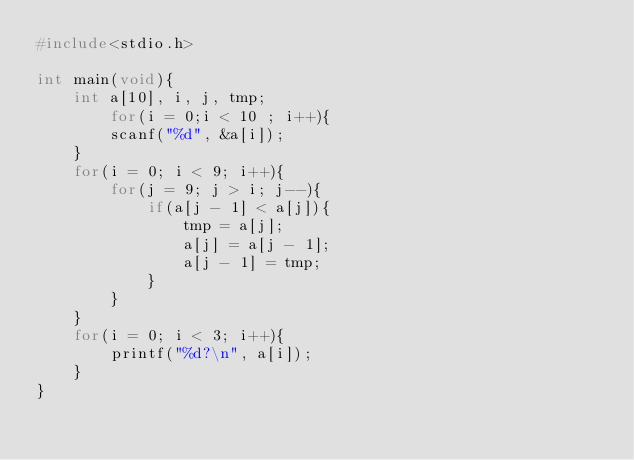<code> <loc_0><loc_0><loc_500><loc_500><_C_>#include<stdio.h>

int main(void){
	int a[10], i, j, tmp;
        for(i = 0;i < 10 ; i++){
		scanf("%d", &a[i]);
	}
	for(i = 0; i < 9; i++){
		for(j = 9; j > i; j--){
			if(a[j - 1] < a[j]){
				tmp = a[j];
				a[j] = a[j - 1];
				a[j - 1] = tmp;
			}
		}
	}
	for(i = 0; i < 3; i++){
		printf("%d?\n", a[i]);
	}
}</code> 